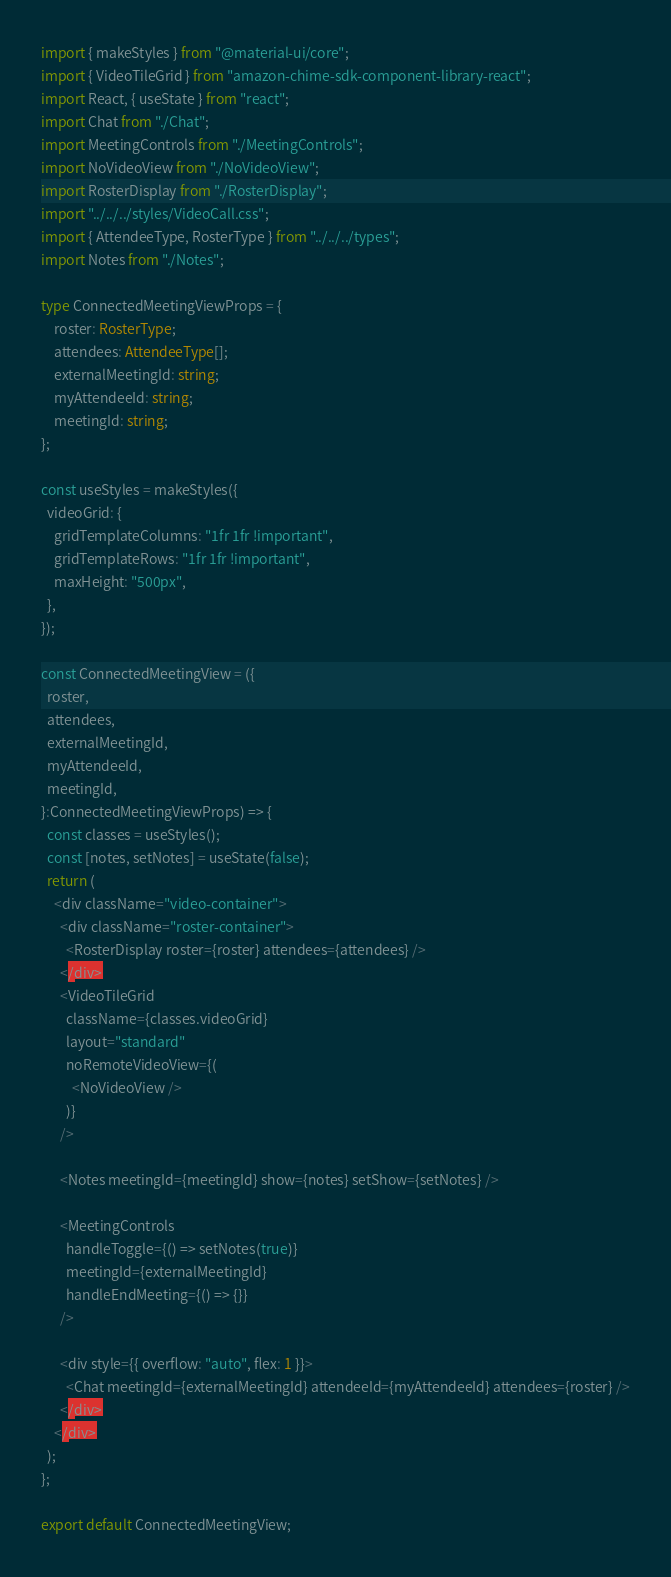<code> <loc_0><loc_0><loc_500><loc_500><_TypeScript_>import { makeStyles } from "@material-ui/core";
import { VideoTileGrid } from "amazon-chime-sdk-component-library-react";
import React, { useState } from "react";
import Chat from "./Chat";
import MeetingControls from "./MeetingControls";
import NoVideoView from "./NoVideoView";
import RosterDisplay from "./RosterDisplay";
import "../../../styles/VideoCall.css";
import { AttendeeType, RosterType } from "../../../types";
import Notes from "./Notes";

type ConnectedMeetingViewProps = {
    roster: RosterType;
    attendees: AttendeeType[];
    externalMeetingId: string;
    myAttendeeId: string;
    meetingId: string;
};

const useStyles = makeStyles({
  videoGrid: {
    gridTemplateColumns: "1fr 1fr !important",
    gridTemplateRows: "1fr 1fr !important",
    maxHeight: "500px",
  },
});

const ConnectedMeetingView = ({
  roster,
  attendees,
  externalMeetingId,
  myAttendeeId,
  meetingId,
}:ConnectedMeetingViewProps) => {
  const classes = useStyles();
  const [notes, setNotes] = useState(false);
  return (
    <div className="video-container">
      <div className="roster-container">
        <RosterDisplay roster={roster} attendees={attendees} />
      </div>
      <VideoTileGrid
        className={classes.videoGrid}
        layout="standard"
        noRemoteVideoView={(
          <NoVideoView />
        )}
      />

      <Notes meetingId={meetingId} show={notes} setShow={setNotes} />

      <MeetingControls
        handleToggle={() => setNotes(true)}
        meetingId={externalMeetingId}
        handleEndMeeting={() => {}}
      />

      <div style={{ overflow: "auto", flex: 1 }}>
        <Chat meetingId={externalMeetingId} attendeeId={myAttendeeId} attendees={roster} />
      </div>
    </div>
  );
};

export default ConnectedMeetingView;
</code> 